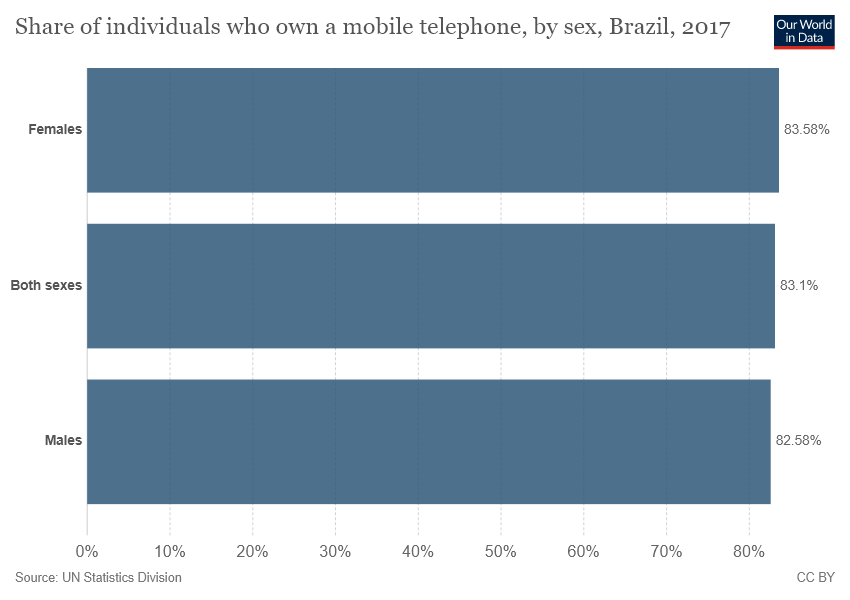Draw attention to some important aspects in this diagram. In Brazil, approximately 83.58% of females own a mobile telephone. The average of females and males who own a mobile telephone is 83.08. 